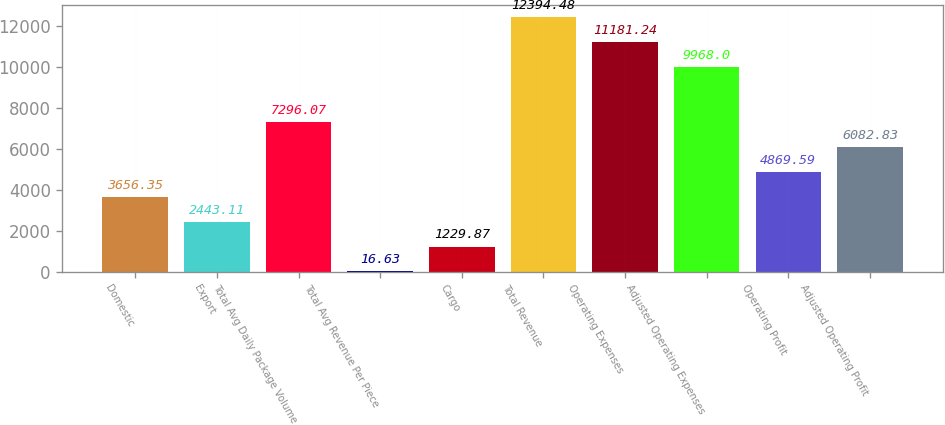Convert chart to OTSL. <chart><loc_0><loc_0><loc_500><loc_500><bar_chart><fcel>Domestic<fcel>Export<fcel>Total Avg Daily Package Volume<fcel>Total Avg Revenue Per Piece<fcel>Cargo<fcel>Total Revenue<fcel>Operating Expenses<fcel>Adjusted Operating Expenses<fcel>Operating Profit<fcel>Adjusted Operating Profit<nl><fcel>3656.35<fcel>2443.11<fcel>7296.07<fcel>16.63<fcel>1229.87<fcel>12394.5<fcel>11181.2<fcel>9968<fcel>4869.59<fcel>6082.83<nl></chart> 